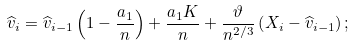<formula> <loc_0><loc_0><loc_500><loc_500>\widehat { v } _ { i } = \widehat { v } _ { i - 1 } \left ( 1 - \frac { a _ { 1 } } { n } \right ) + \frac { a _ { 1 } K } { n } + \frac { \vartheta } { n ^ { 2 / 3 } } \left ( X _ { i } - \widehat { v } _ { i - 1 } \right ) ;</formula> 